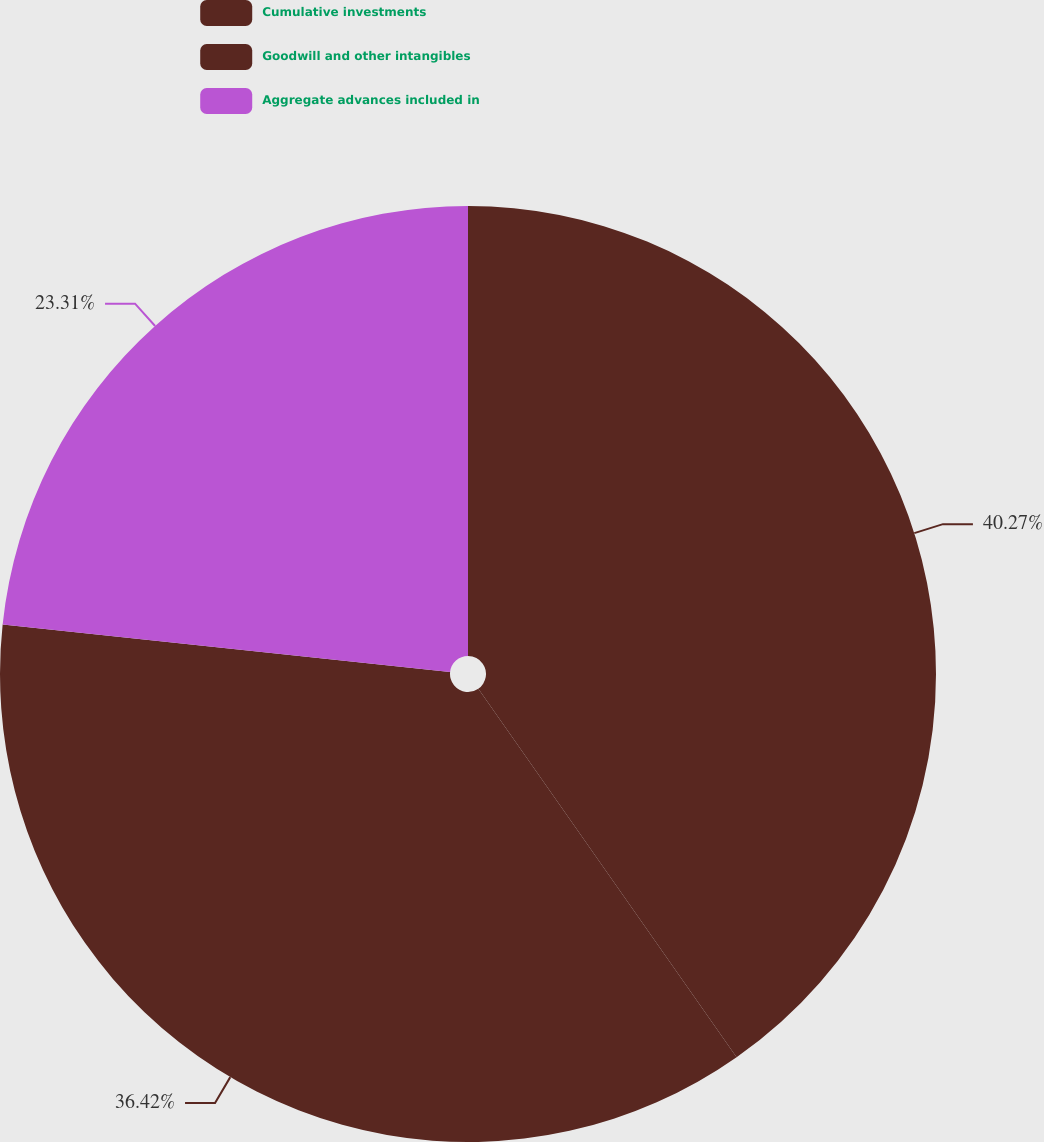Convert chart. <chart><loc_0><loc_0><loc_500><loc_500><pie_chart><fcel>Cumulative investments<fcel>Goodwill and other intangibles<fcel>Aggregate advances included in<nl><fcel>40.27%<fcel>36.42%<fcel>23.31%<nl></chart> 